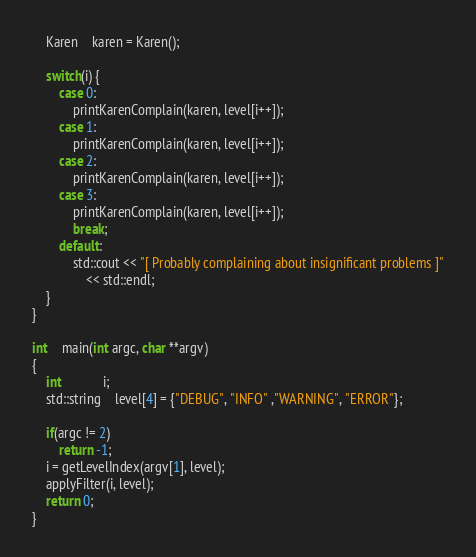<code> <loc_0><loc_0><loc_500><loc_500><_C++_>	Karen	karen = Karen();

	switch(i) {
		case 0:
			printKarenComplain(karen, level[i++]);
		case 1:
			printKarenComplain(karen, level[i++]);
		case 2:
			printKarenComplain(karen, level[i++]);
		case 3:
			printKarenComplain(karen, level[i++]);
			break;
		default:
			std::cout << "[ Probably complaining about insignificant problems ]"
				<< std::endl;
	}
}

int	main(int argc, char **argv)
{
	int			i;
	std::string	level[4] = {"DEBUG", "INFO" ,"WARNING", "ERROR"};
	
	if(argc != 2)
		return -1;
	i = getLevelIndex(argv[1], level);
	applyFilter(i, level);
	return 0;
}
</code> 